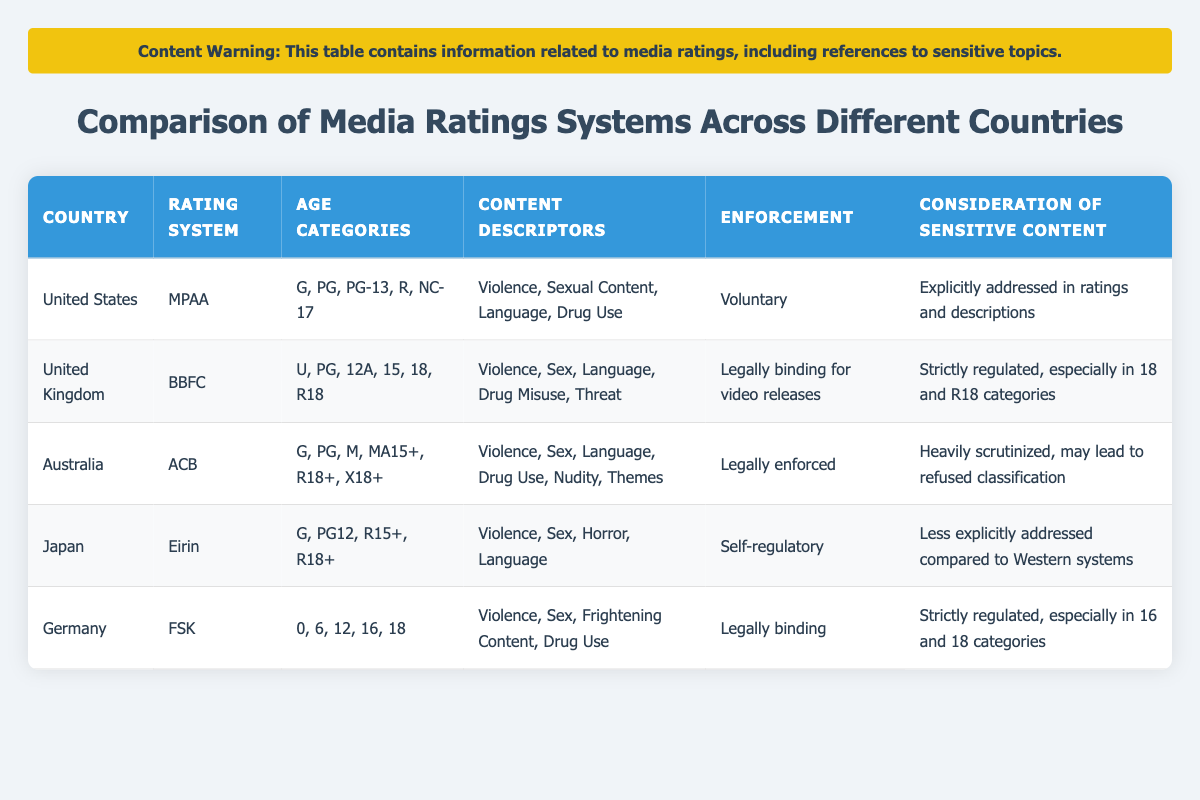What are the age categories used by Germany's rating system? The table lists the age categories used by Germany's FSK rating system as follows: 0, 6, 12, 16, 18. This information can be directly retrieved from the "Age Categories" column corresponding to Germany.
Answer: 0, 6, 12, 16, 18 Is the enforcement of the BBFC rating system in the UK voluntary? According to the table, the enforcement for the BBFC rating system is "Legally binding for video releases," which means it is not voluntary. Therefore, the statement is false.
Answer: No Which country has a self-regulatory rating system? The table indicates that Japan uses a self-regulatory rating system called Eirin. By checking the "Rating System" column, Japan's entry confirms this information.
Answer: Japan How many countries have strictly regulated considerations of sexual violence in their media rating systems? The table shows three countries (United Kingdom, Australia, and Germany) that explicitly mention strict regulations for the consideration of sexual violence in their rating systems. They are clearly listed under the “Consideration of Sexual Violence” column.
Answer: Three Which country has the most extensive list of age categories and what are they? Australia has the most extensive list of age categories, which include G, PG, M, MA15+, R18+, and X18+. This information can be confirmed by comparing the different age category lists across all countries.
Answer: G, PG, M, MA15+, R18+, X18+ Does the MPAA consider "sexual content" as a content descriptor? Referring to the “Content Descriptors” column for the MPAA rating system in the United States, "Sexual Content" is explicitly listed. Thus, the consideration is true.
Answer: Yes In which country's rating system might a film be refused classification due to scrutiny of sexual violence? The ACB in Australia is noted for being heavily scrutinized, which may result in the refusal of classification for certain films. By reviewing the specifics in the column for "Consideration of Sexual Violence," Australia is the answer.
Answer: Australia How many total age categories are listed for the MPAA in the United States? The table indicates that the MPAA includes a total of five age categories: G, PG, PG-13, R, and NC-17. Counting these from the “Age Categories” column confirms the total.
Answer: Five 